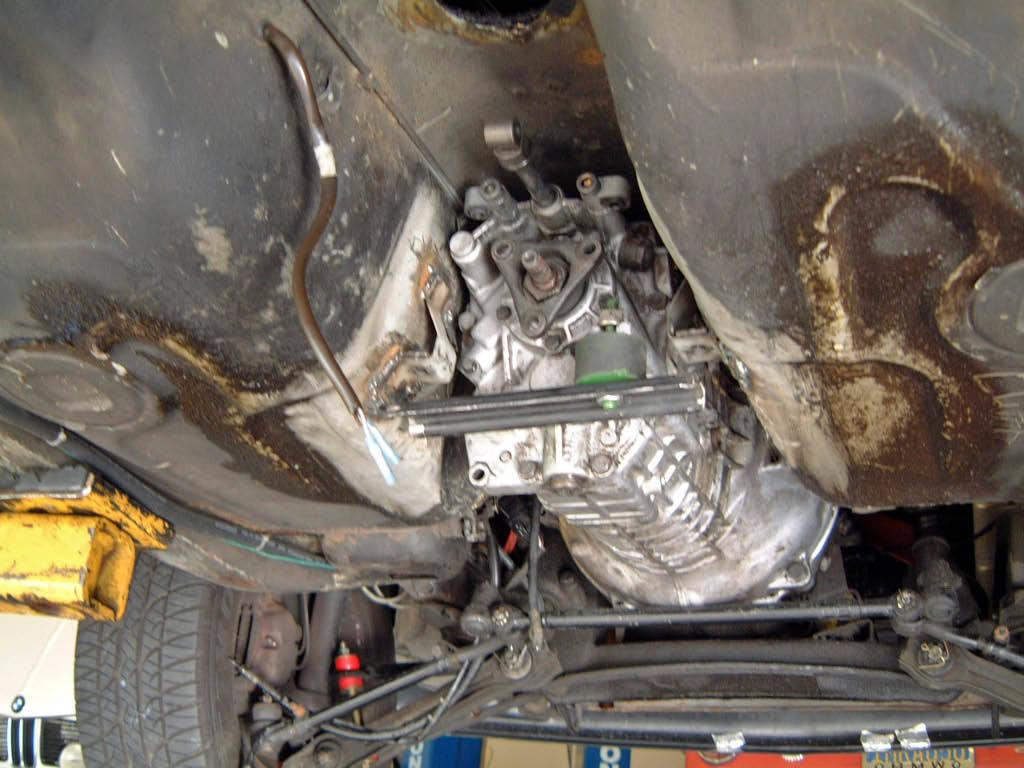What type of subject is depicted in the image? The image contains internal parts of a vehicle. Can you describe any specific components visible in the image? Unfortunately, without more specific information about the vehicle or its internal parts, it is difficult to provide a detailed description. What type of scissors are used to perform addition in the image? There are no scissors or addition calculations present in the image; it contains internal parts of a vehicle. 